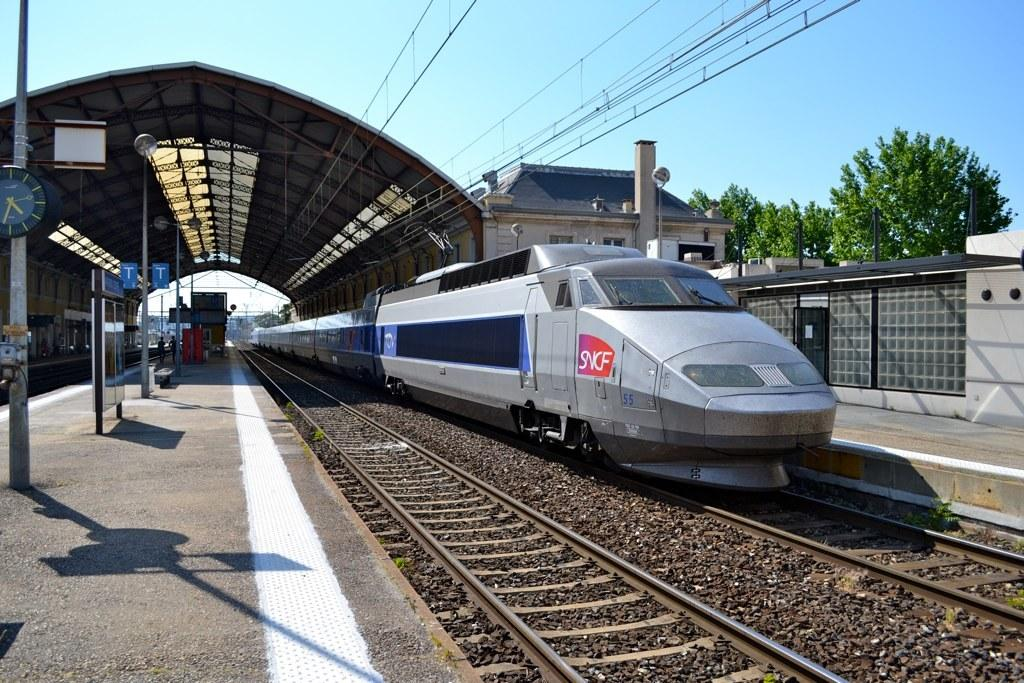<image>
Describe the image concisely. A high-speed train says SNCF on the nose. 